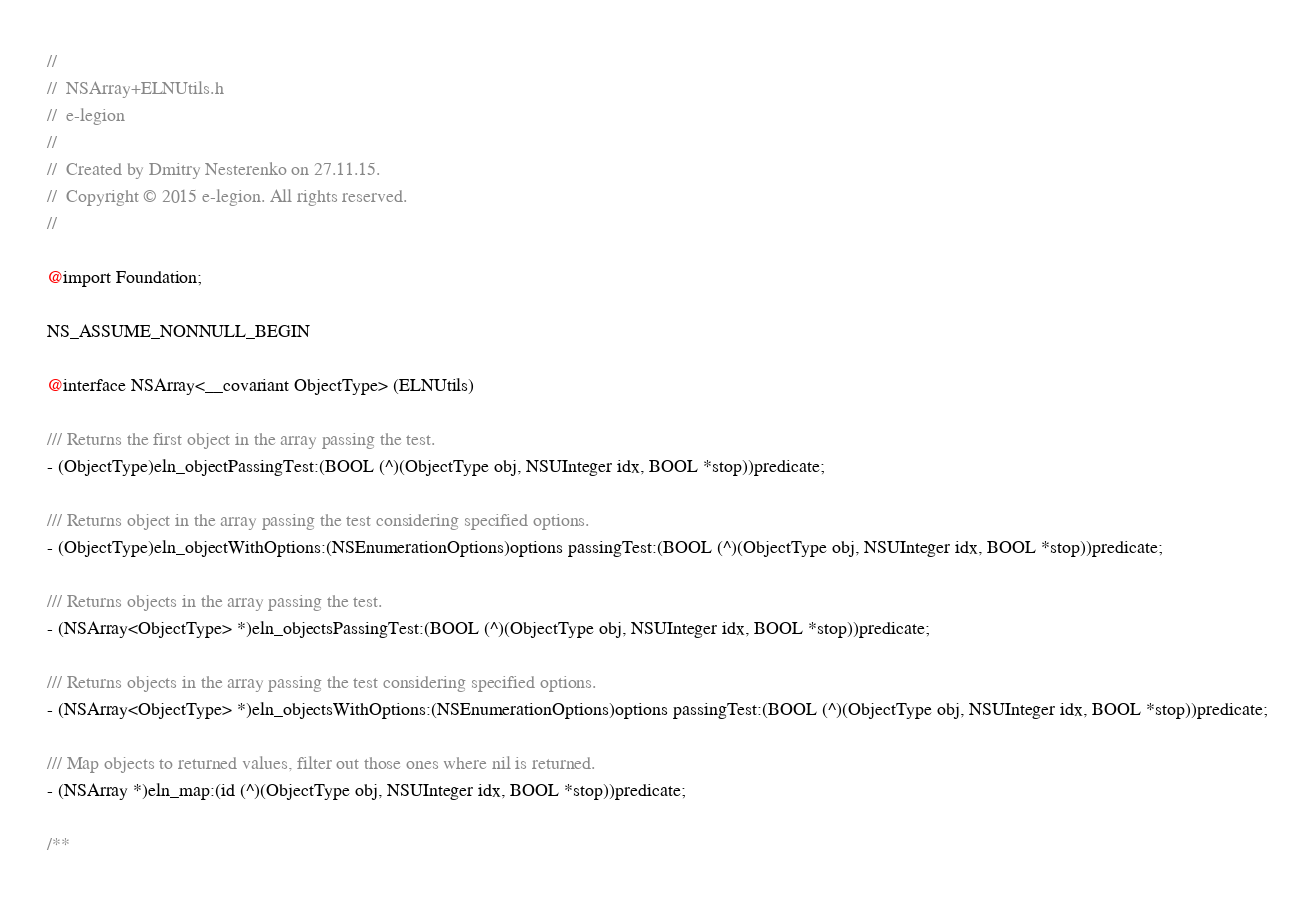Convert code to text. <code><loc_0><loc_0><loc_500><loc_500><_C_>//
//  NSArray+ELNUtils.h
//  e-legion
//
//  Created by Dmitry Nesterenko on 27.11.15.
//  Copyright © 2015 e-legion. All rights reserved.
//

@import Foundation;

NS_ASSUME_NONNULL_BEGIN

@interface NSArray<__covariant ObjectType> (ELNUtils)

/// Returns the first object in the array passing the test.
- (ObjectType)eln_objectPassingTest:(BOOL (^)(ObjectType obj, NSUInteger idx, BOOL *stop))predicate;

/// Returns object in the array passing the test considering specified options.
- (ObjectType)eln_objectWithOptions:(NSEnumerationOptions)options passingTest:(BOOL (^)(ObjectType obj, NSUInteger idx, BOOL *stop))predicate;

/// Returns objects in the array passing the test.
- (NSArray<ObjectType> *)eln_objectsPassingTest:(BOOL (^)(ObjectType obj, NSUInteger idx, BOOL *stop))predicate;

/// Returns objects in the array passing the test considering specified options.
- (NSArray<ObjectType> *)eln_objectsWithOptions:(NSEnumerationOptions)options passingTest:(BOOL (^)(ObjectType obj, NSUInteger idx, BOOL *stop))predicate;

/// Map objects to returned values, filter out those ones where nil is returned.
- (NSArray *)eln_map:(id (^)(ObjectType obj, NSUInteger idx, BOOL *stop))predicate;

/** </code> 